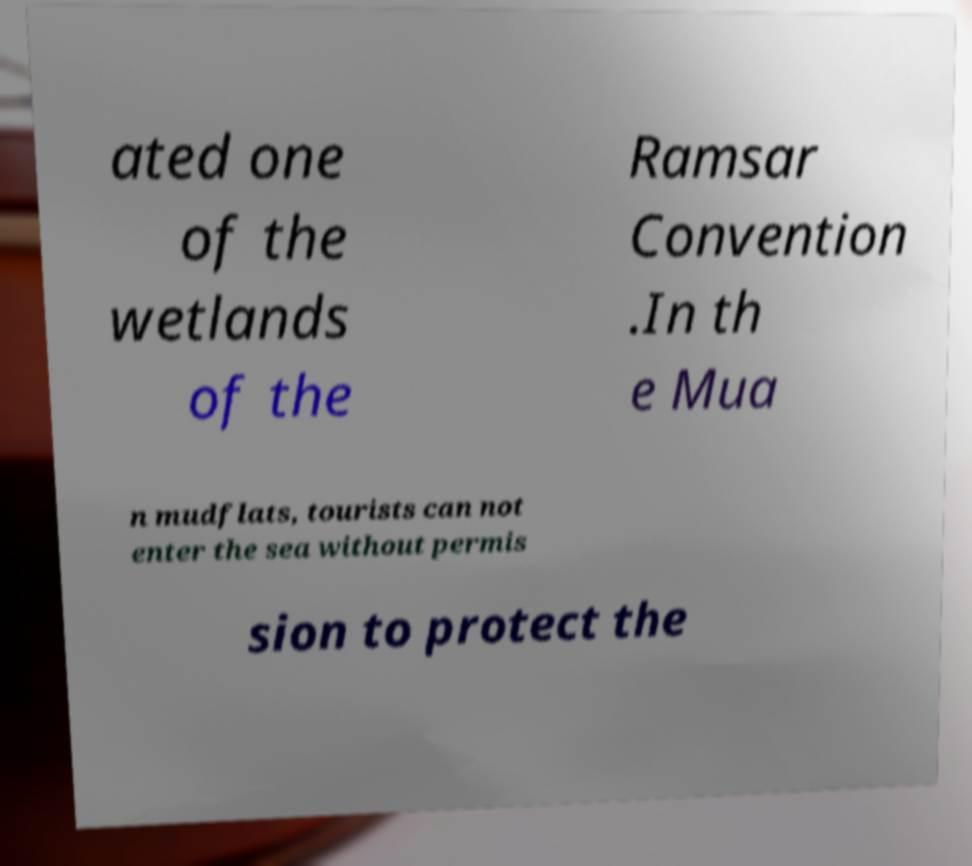There's text embedded in this image that I need extracted. Can you transcribe it verbatim? ated one of the wetlands of the Ramsar Convention .In th e Mua n mudflats, tourists can not enter the sea without permis sion to protect the 